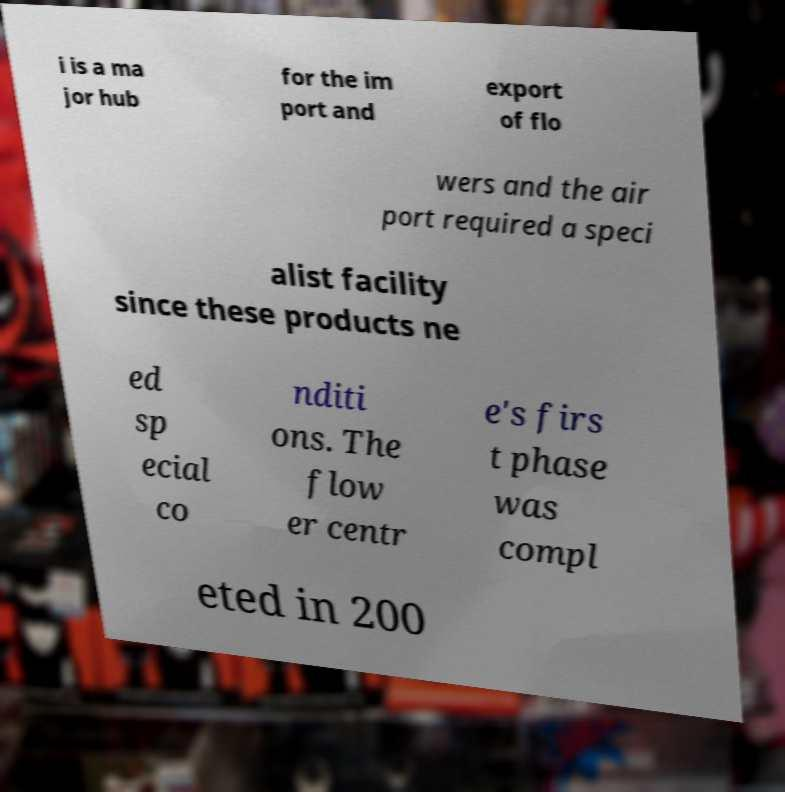Please read and relay the text visible in this image. What does it say? i is a ma jor hub for the im port and export of flo wers and the air port required a speci alist facility since these products ne ed sp ecial co nditi ons. The flow er centr e's firs t phase was compl eted in 200 